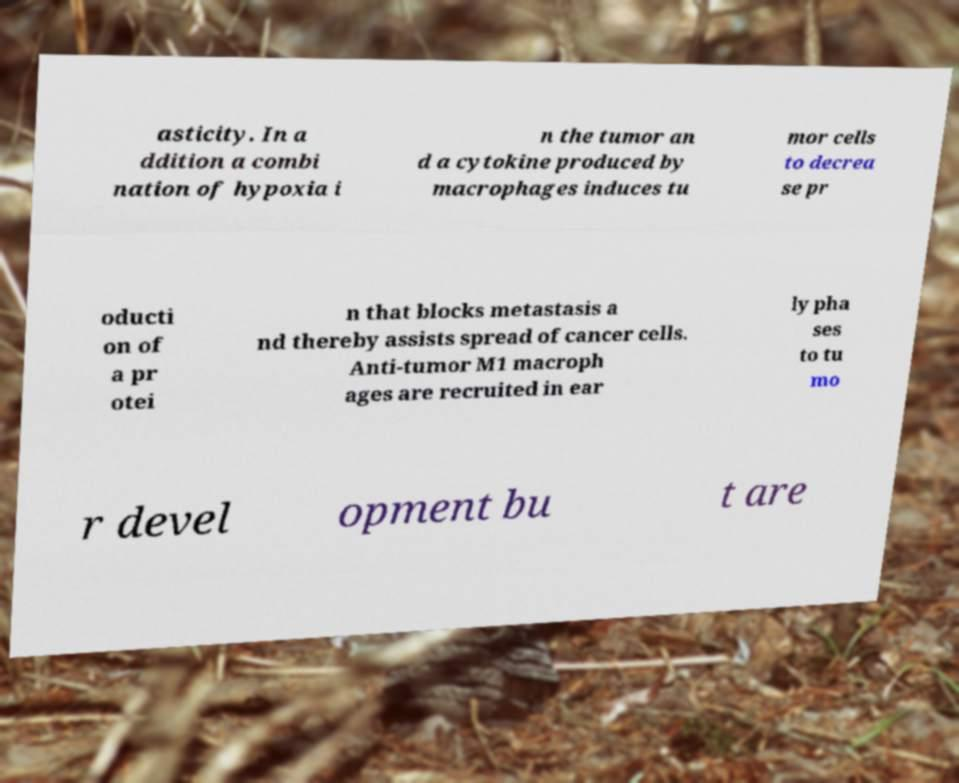What messages or text are displayed in this image? I need them in a readable, typed format. asticity. In a ddition a combi nation of hypoxia i n the tumor an d a cytokine produced by macrophages induces tu mor cells to decrea se pr oducti on of a pr otei n that blocks metastasis a nd thereby assists spread of cancer cells. Anti-tumor M1 macroph ages are recruited in ear ly pha ses to tu mo r devel opment bu t are 